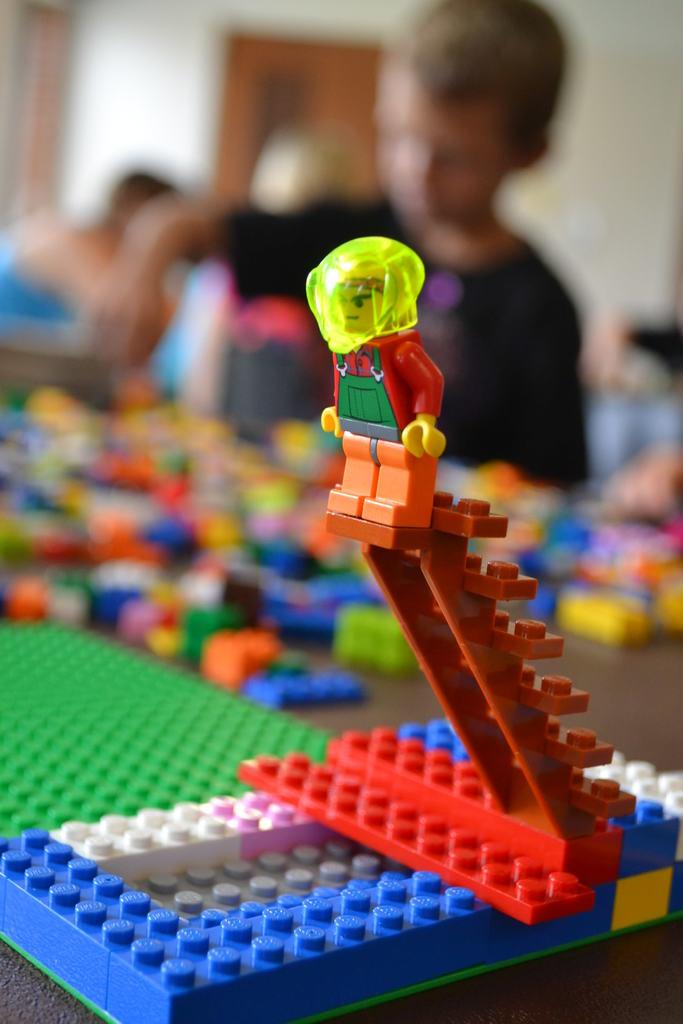What objects are on the table in the foreground of the image? There are building blocks and toys on a table in the foreground of the image. Can you describe the people in the background? There is a group of people in the background of the image. What architectural features are visible in the background? There is a door and a wall in the background of the image. What type of location might the image have been taken in? The image may have been taken in a hall. Can you tell me how many cabbages are floating in the river in the image? There is no river or cabbages present in the image. What type of cover is being used to protect the toys from the sun in the image? There is no cover visible in the image; the toys are on a table in the foreground. 